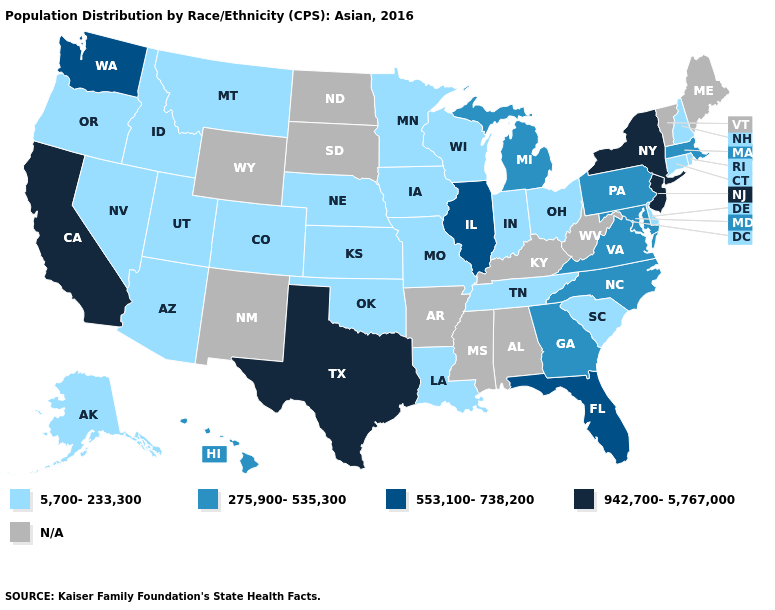What is the value of Idaho?
Concise answer only. 5,700-233,300. Name the states that have a value in the range 275,900-535,300?
Give a very brief answer. Georgia, Hawaii, Maryland, Massachusetts, Michigan, North Carolina, Pennsylvania, Virginia. Which states have the lowest value in the USA?
Concise answer only. Alaska, Arizona, Colorado, Connecticut, Delaware, Idaho, Indiana, Iowa, Kansas, Louisiana, Minnesota, Missouri, Montana, Nebraska, Nevada, New Hampshire, Ohio, Oklahoma, Oregon, Rhode Island, South Carolina, Tennessee, Utah, Wisconsin. What is the value of Oregon?
Be succinct. 5,700-233,300. What is the value of North Dakota?
Quick response, please. N/A. Name the states that have a value in the range 275,900-535,300?
Write a very short answer. Georgia, Hawaii, Maryland, Massachusetts, Michigan, North Carolina, Pennsylvania, Virginia. What is the lowest value in the South?
Keep it brief. 5,700-233,300. What is the value of Maine?
Quick response, please. N/A. Which states have the lowest value in the USA?
Write a very short answer. Alaska, Arizona, Colorado, Connecticut, Delaware, Idaho, Indiana, Iowa, Kansas, Louisiana, Minnesota, Missouri, Montana, Nebraska, Nevada, New Hampshire, Ohio, Oklahoma, Oregon, Rhode Island, South Carolina, Tennessee, Utah, Wisconsin. What is the value of Massachusetts?
Be succinct. 275,900-535,300. Does the first symbol in the legend represent the smallest category?
Give a very brief answer. Yes. Is the legend a continuous bar?
Answer briefly. No. Among the states that border Ohio , does Indiana have the highest value?
Concise answer only. No. Name the states that have a value in the range 5,700-233,300?
Be succinct. Alaska, Arizona, Colorado, Connecticut, Delaware, Idaho, Indiana, Iowa, Kansas, Louisiana, Minnesota, Missouri, Montana, Nebraska, Nevada, New Hampshire, Ohio, Oklahoma, Oregon, Rhode Island, South Carolina, Tennessee, Utah, Wisconsin. 